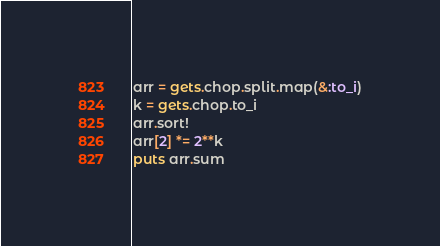<code> <loc_0><loc_0><loc_500><loc_500><_Ruby_>arr = gets.chop.split.map(&:to_i)
k = gets.chop.to_i
arr.sort!
arr[2] *= 2**k
puts arr.sum
</code> 